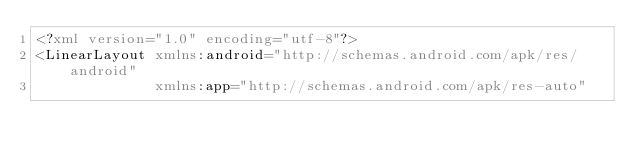Convert code to text. <code><loc_0><loc_0><loc_500><loc_500><_XML_><?xml version="1.0" encoding="utf-8"?>
<LinearLayout xmlns:android="http://schemas.android.com/apk/res/android"
              xmlns:app="http://schemas.android.com/apk/res-auto"</code> 